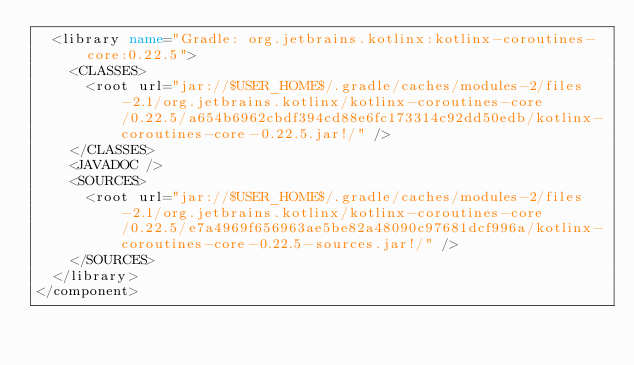<code> <loc_0><loc_0><loc_500><loc_500><_XML_>  <library name="Gradle: org.jetbrains.kotlinx:kotlinx-coroutines-core:0.22.5">
    <CLASSES>
      <root url="jar://$USER_HOME$/.gradle/caches/modules-2/files-2.1/org.jetbrains.kotlinx/kotlinx-coroutines-core/0.22.5/a654b6962cbdf394cd88e6fc173314c92dd50edb/kotlinx-coroutines-core-0.22.5.jar!/" />
    </CLASSES>
    <JAVADOC />
    <SOURCES>
      <root url="jar://$USER_HOME$/.gradle/caches/modules-2/files-2.1/org.jetbrains.kotlinx/kotlinx-coroutines-core/0.22.5/e7a4969f656963ae5be82a48090c97681dcf996a/kotlinx-coroutines-core-0.22.5-sources.jar!/" />
    </SOURCES>
  </library>
</component></code> 